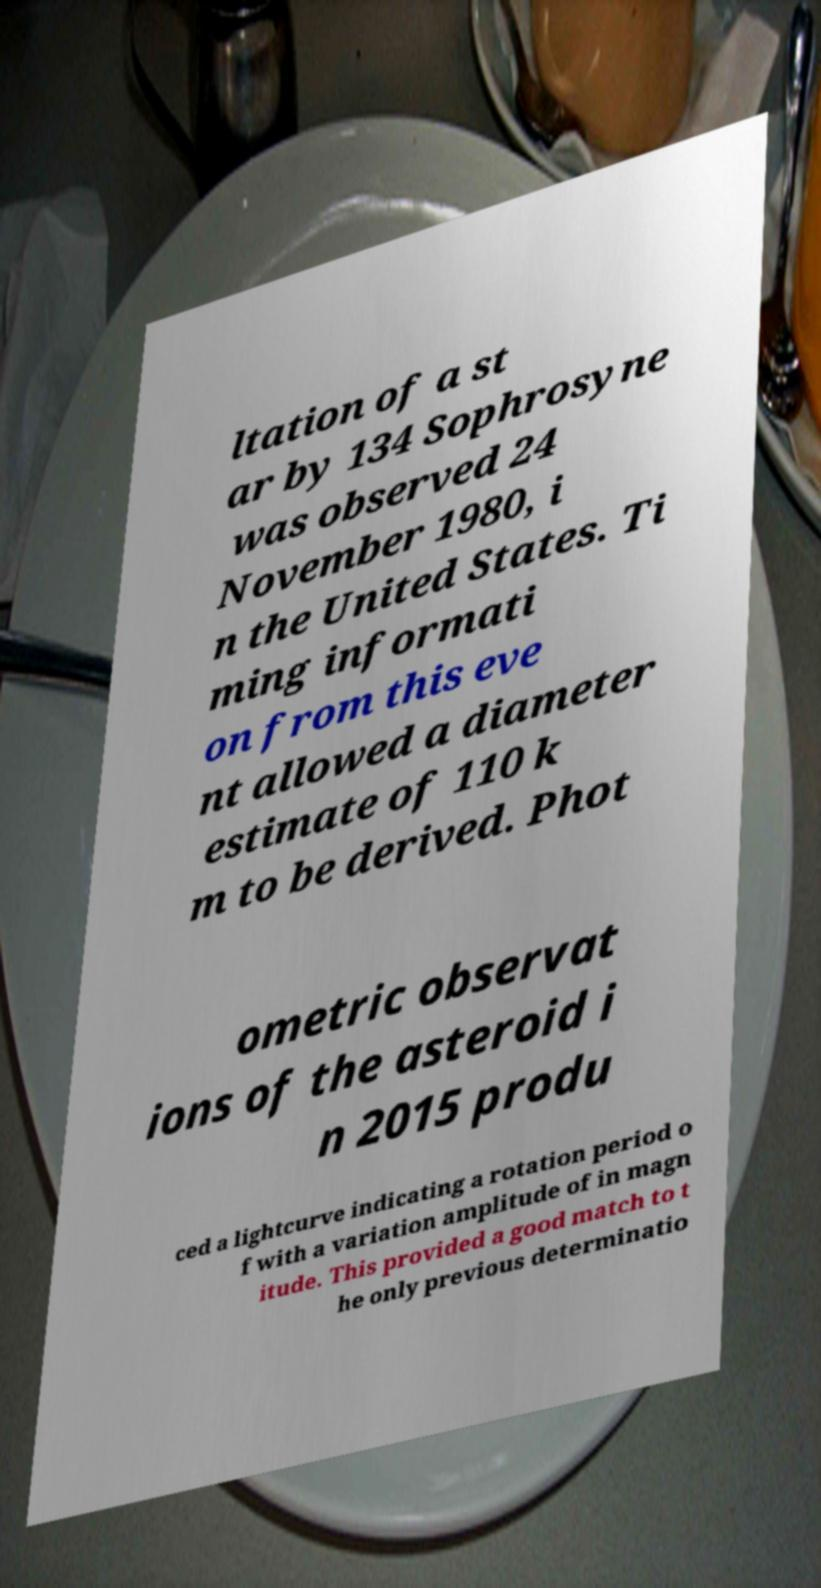Could you extract and type out the text from this image? ltation of a st ar by 134 Sophrosyne was observed 24 November 1980, i n the United States. Ti ming informati on from this eve nt allowed a diameter estimate of 110 k m to be derived. Phot ometric observat ions of the asteroid i n 2015 produ ced a lightcurve indicating a rotation period o f with a variation amplitude of in magn itude. This provided a good match to t he only previous determinatio 